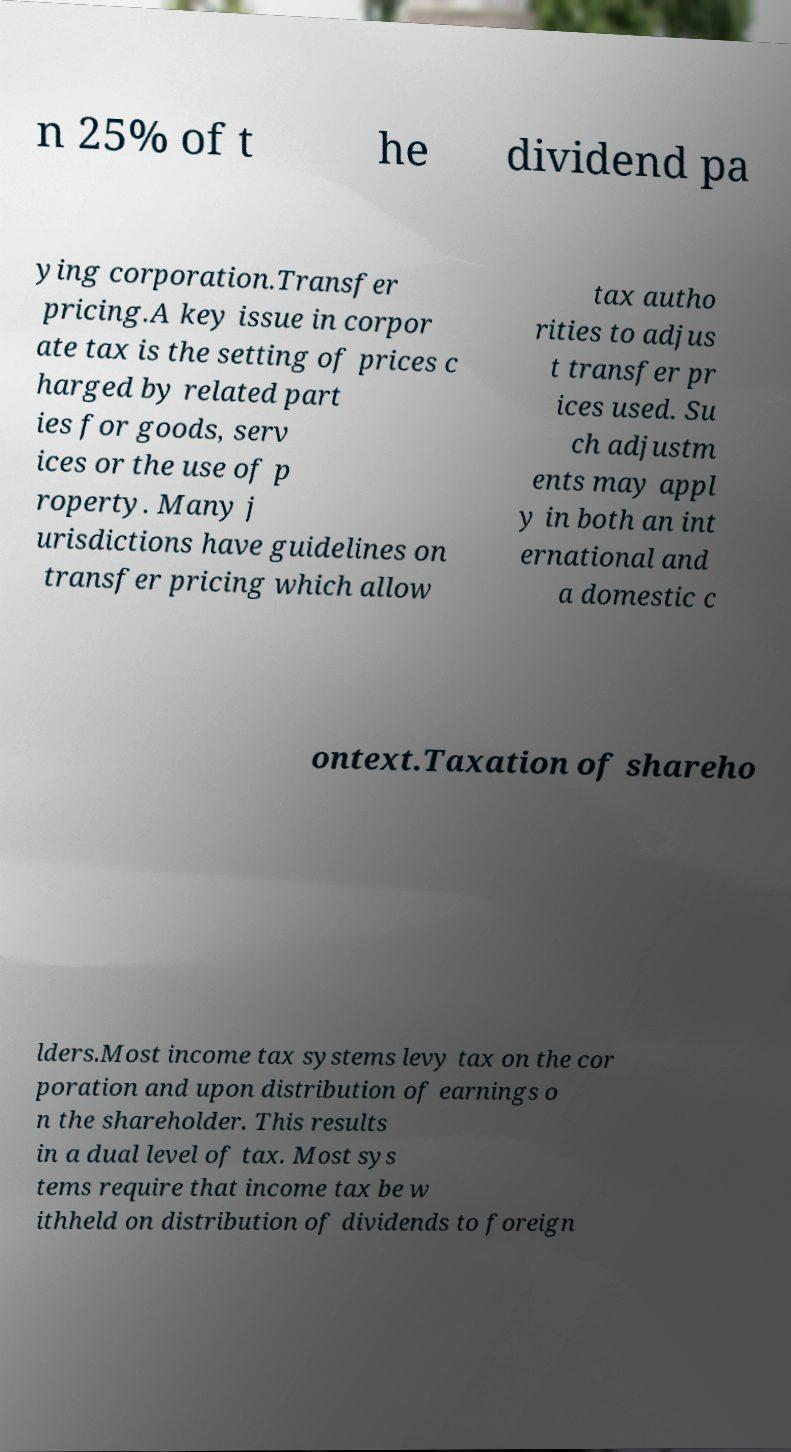For documentation purposes, I need the text within this image transcribed. Could you provide that? n 25% of t he dividend pa ying corporation.Transfer pricing.A key issue in corpor ate tax is the setting of prices c harged by related part ies for goods, serv ices or the use of p roperty. Many j urisdictions have guidelines on transfer pricing which allow tax autho rities to adjus t transfer pr ices used. Su ch adjustm ents may appl y in both an int ernational and a domestic c ontext.Taxation of shareho lders.Most income tax systems levy tax on the cor poration and upon distribution of earnings o n the shareholder. This results in a dual level of tax. Most sys tems require that income tax be w ithheld on distribution of dividends to foreign 